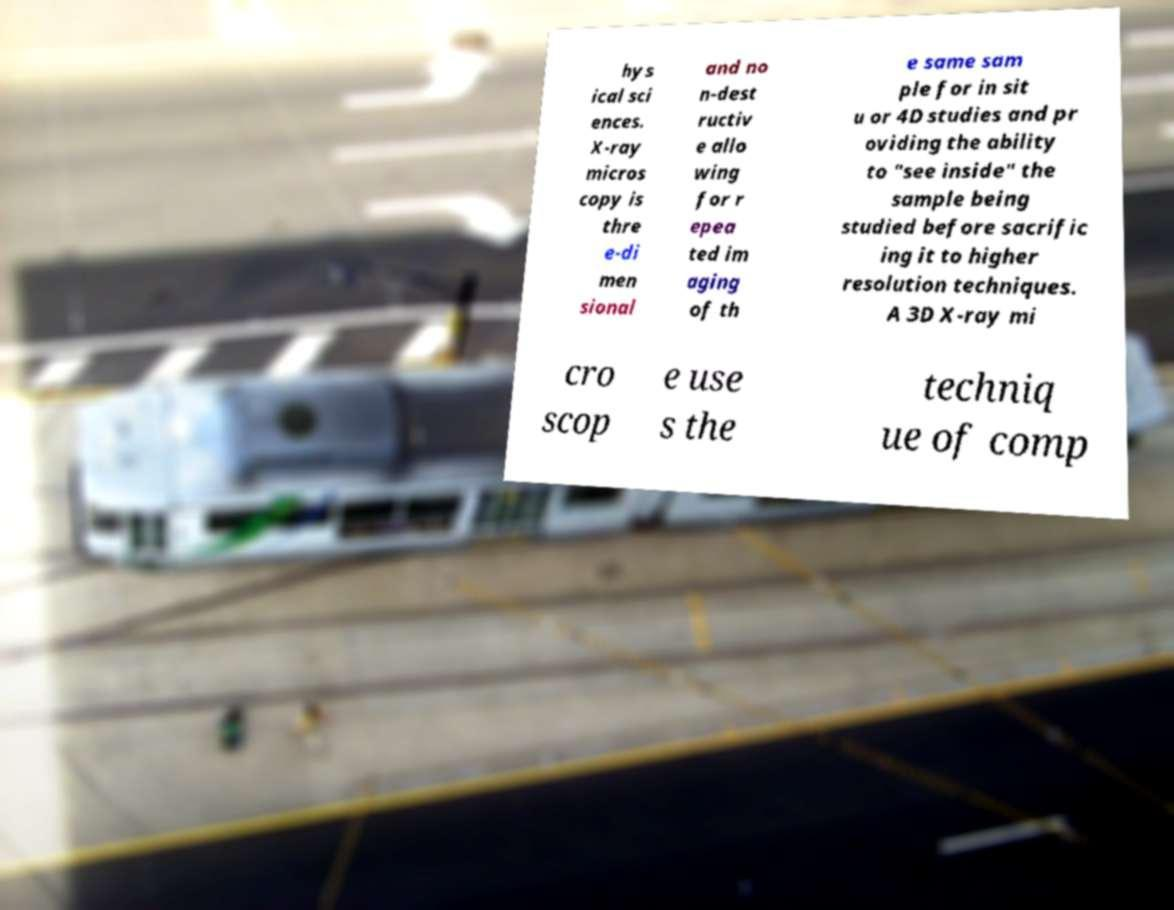Please read and relay the text visible in this image. What does it say? hys ical sci ences. X-ray micros copy is thre e-di men sional and no n-dest ructiv e allo wing for r epea ted im aging of th e same sam ple for in sit u or 4D studies and pr oviding the ability to "see inside" the sample being studied before sacrific ing it to higher resolution techniques. A 3D X-ray mi cro scop e use s the techniq ue of comp 